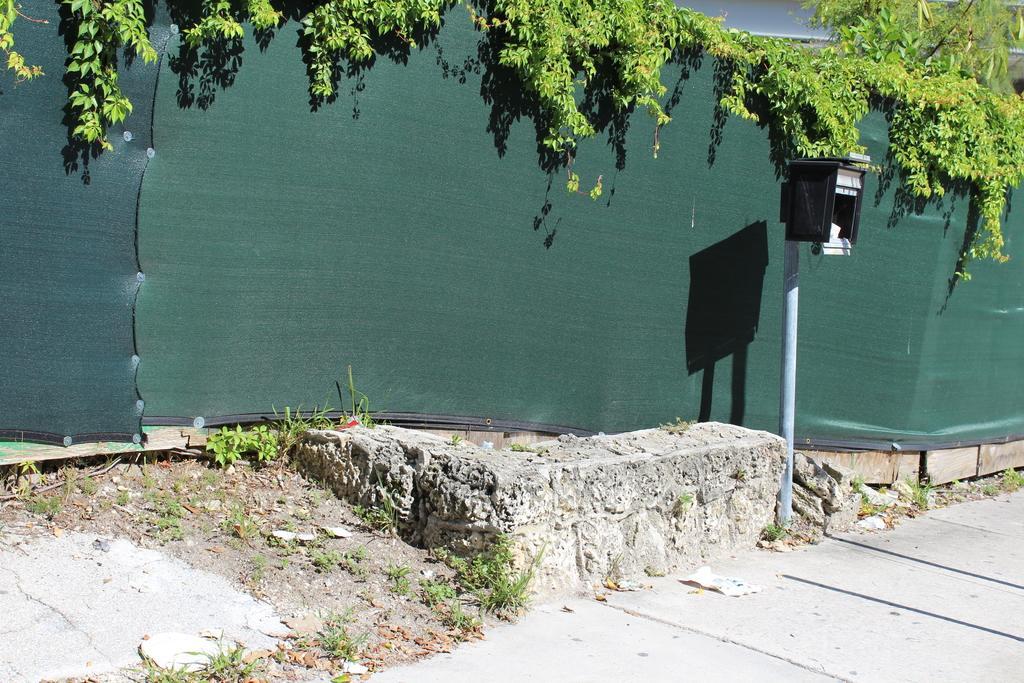In one or two sentences, can you explain what this image depicts? In this picture I can see there is a walk way, a pole and there is a green color wall in the backdrop. 